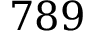<formula> <loc_0><loc_0><loc_500><loc_500>7 8 9</formula> 